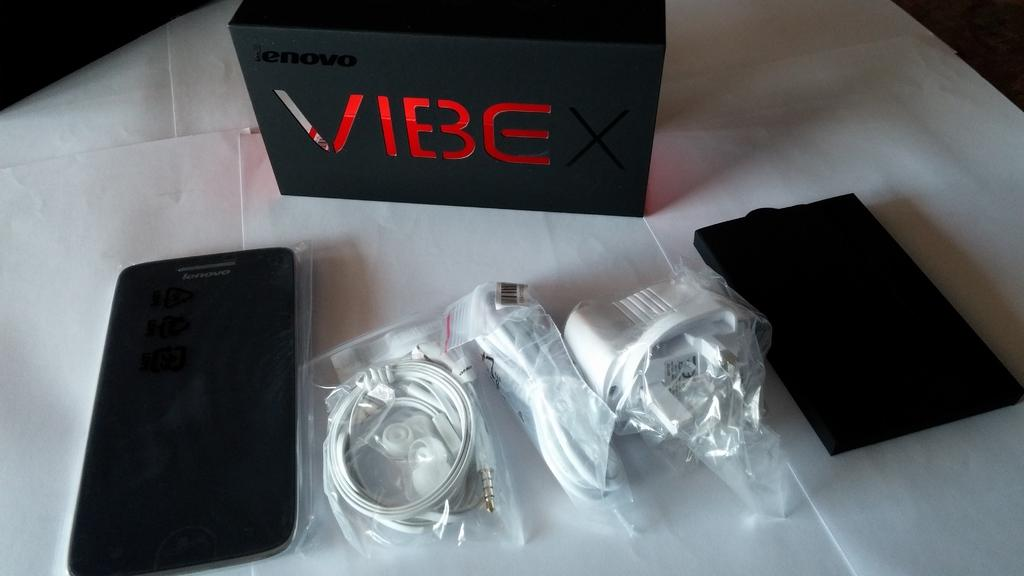<image>
Create a compact narrative representing the image presented. With VIBE, you get all these chargers and carrying case as well. 